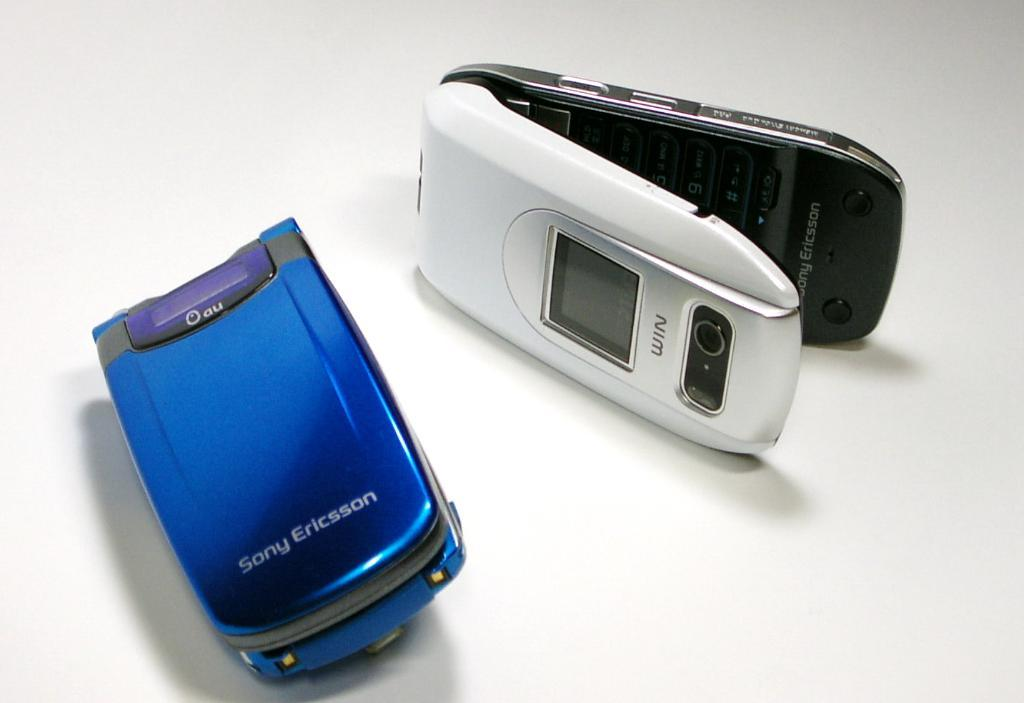<image>
Share a concise interpretation of the image provided. A blue Sony Ericsson flip phone lays next to a White Sony Ericsson flip phone 